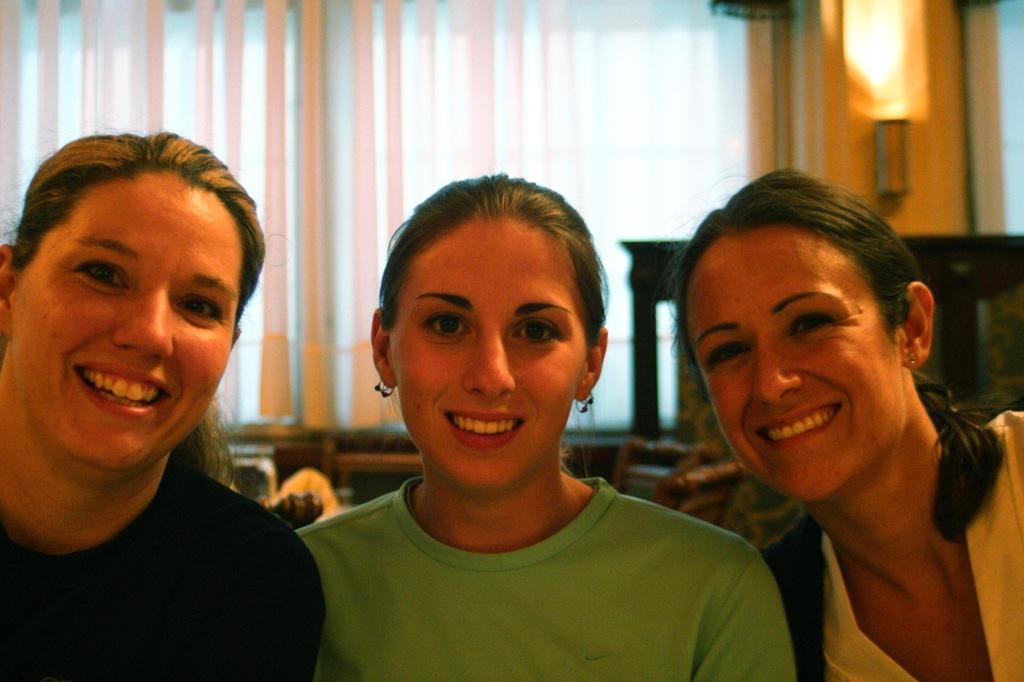Please provide a concise description of this image. In this picture we can observe three women. All of them are smiling. Two of them are wearing black and green color T shirts. In the background we can observe curtains. There is light fixed to the wall on the right side. 